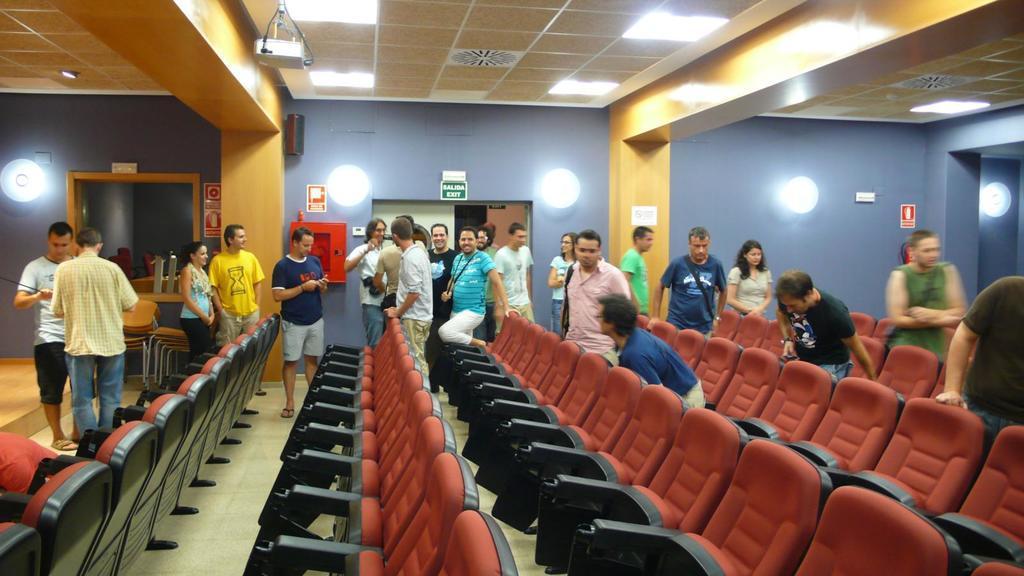Describe this image in one or two sentences. n this image there are group of persons, there is a person truncated towards the left of the image, there is a person truncated towards the right of the image, there are chairs truncated towards the bottom of the image, there is a wall, there are objects on the wall, there are lights, there is roof truncated towards the top of the image, there are lights on the roof. 